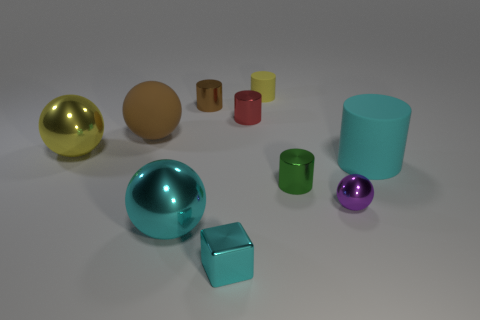Subtract all green cylinders. How many cylinders are left? 4 Subtract all red cylinders. How many cylinders are left? 4 Subtract all spheres. How many objects are left? 6 Subtract all brown matte objects. Subtract all red shiny cylinders. How many objects are left? 8 Add 3 small cubes. How many small cubes are left? 4 Add 10 cyan matte blocks. How many cyan matte blocks exist? 10 Subtract 1 yellow spheres. How many objects are left? 9 Subtract 2 spheres. How many spheres are left? 2 Subtract all blue cylinders. Subtract all brown cubes. How many cylinders are left? 5 Subtract all yellow cubes. How many yellow cylinders are left? 1 